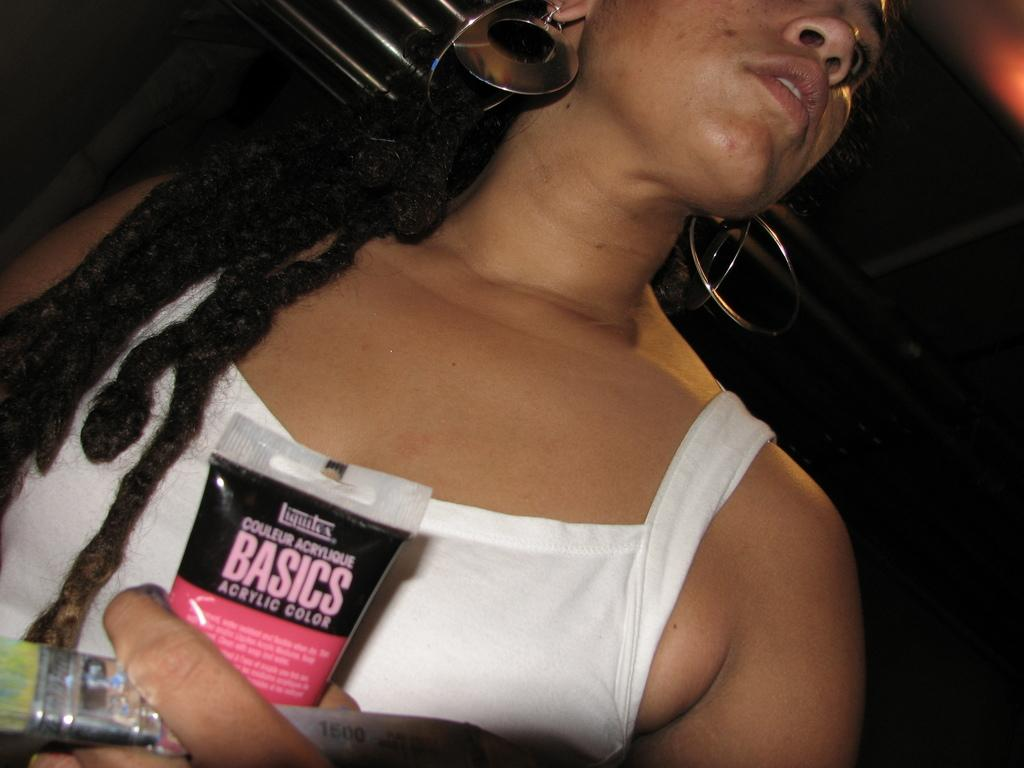Who is present in the image? There is a woman in the image. What is the woman holding in her hands? The woman is holding a tube and a brush in her hands. Can you describe the lighting in the image? There is an orange light in the top right corner of the image. How many chairs are visible in the image? There are no chairs visible in the image. 